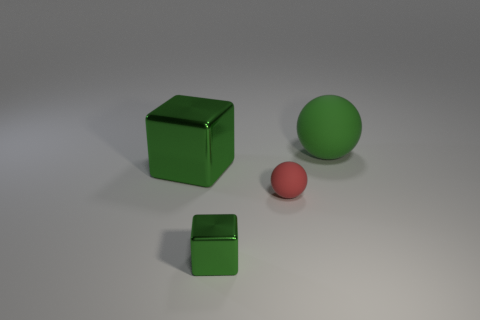Is the size of the green rubber sphere the same as the rubber ball in front of the green rubber ball?
Your response must be concise. No. Are there more large green spheres to the left of the large metallic object than large red metallic balls?
Give a very brief answer. No. There is another cube that is made of the same material as the small block; what is its size?
Give a very brief answer. Large. Are there any small shiny things of the same color as the large metallic thing?
Give a very brief answer. Yes. What number of things are big green rubber balls or objects to the left of the green matte ball?
Your answer should be compact. 4. Is the number of blue blocks greater than the number of balls?
Keep it short and to the point. No. What is the size of the sphere that is the same color as the big cube?
Provide a short and direct response. Large. Are there any red objects made of the same material as the tiny cube?
Offer a terse response. No. What is the shape of the green object that is both in front of the big rubber object and behind the tiny green thing?
Offer a terse response. Cube. What number of other things are the same shape as the green matte object?
Your answer should be compact. 1. 